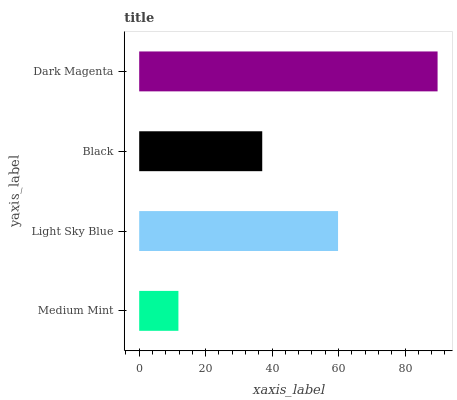Is Medium Mint the minimum?
Answer yes or no. Yes. Is Dark Magenta the maximum?
Answer yes or no. Yes. Is Light Sky Blue the minimum?
Answer yes or no. No. Is Light Sky Blue the maximum?
Answer yes or no. No. Is Light Sky Blue greater than Medium Mint?
Answer yes or no. Yes. Is Medium Mint less than Light Sky Blue?
Answer yes or no. Yes. Is Medium Mint greater than Light Sky Blue?
Answer yes or no. No. Is Light Sky Blue less than Medium Mint?
Answer yes or no. No. Is Light Sky Blue the high median?
Answer yes or no. Yes. Is Black the low median?
Answer yes or no. Yes. Is Dark Magenta the high median?
Answer yes or no. No. Is Medium Mint the low median?
Answer yes or no. No. 